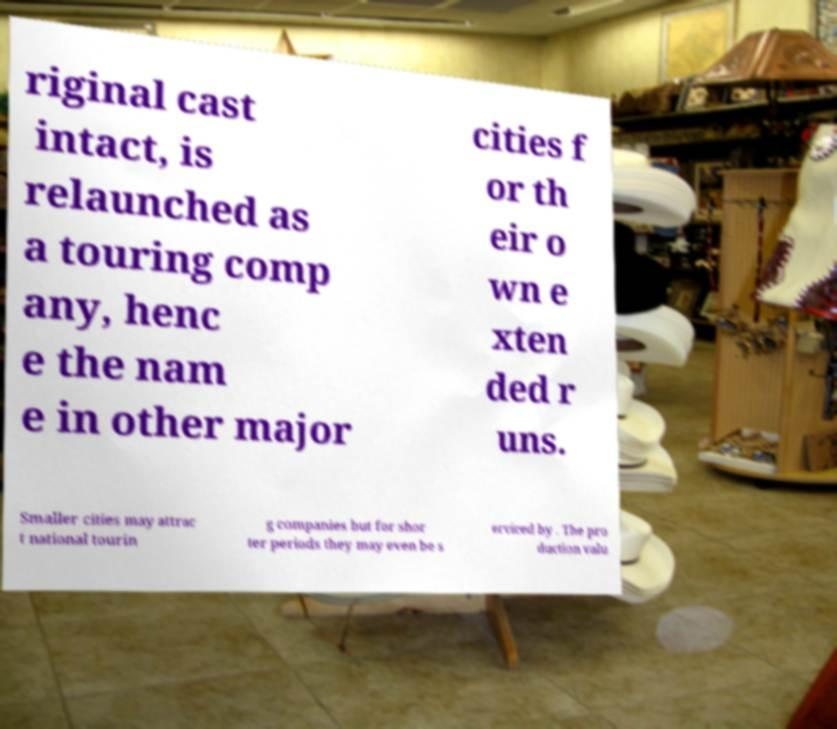Can you read and provide the text displayed in the image?This photo seems to have some interesting text. Can you extract and type it out for me? riginal cast intact, is relaunched as a touring comp any, henc e the nam e in other major cities f or th eir o wn e xten ded r uns. Smaller cities may attrac t national tourin g companies but for shor ter periods they may even be s erviced by . The pro duction valu 